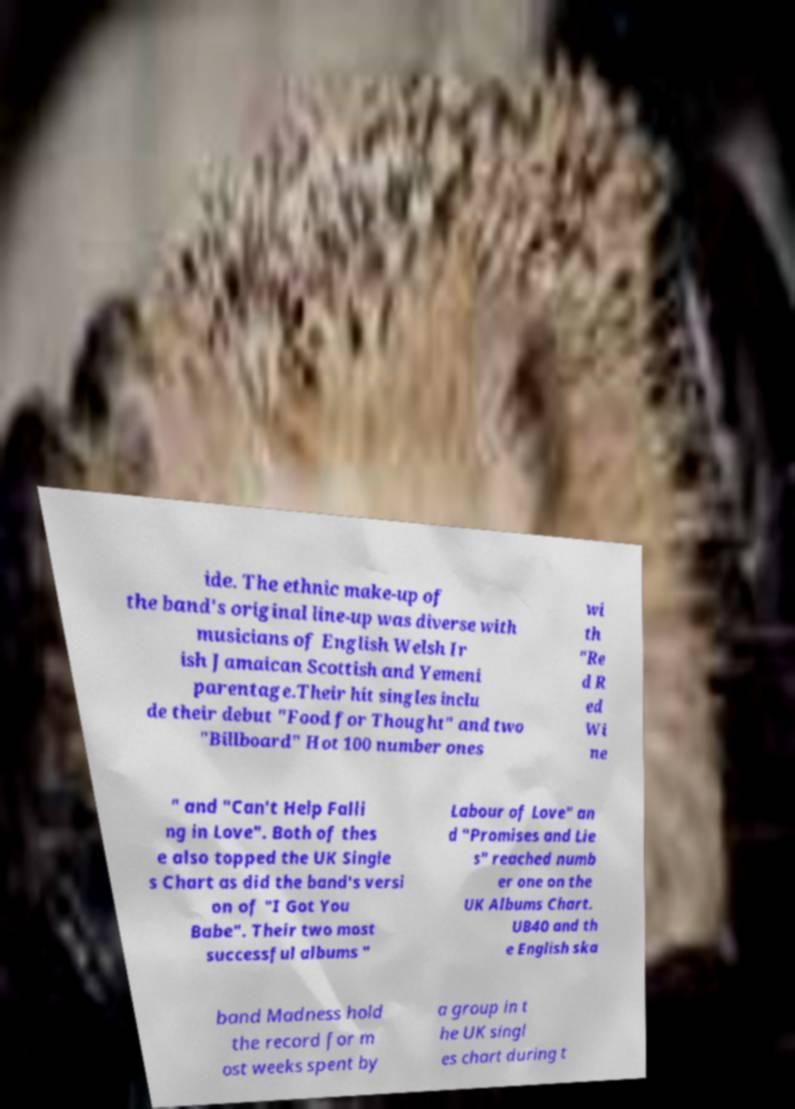Please identify and transcribe the text found in this image. ide. The ethnic make-up of the band's original line-up was diverse with musicians of English Welsh Ir ish Jamaican Scottish and Yemeni parentage.Their hit singles inclu de their debut "Food for Thought" and two "Billboard" Hot 100 number ones wi th "Re d R ed Wi ne " and "Can't Help Falli ng in Love". Both of thes e also topped the UK Single s Chart as did the band's versi on of "I Got You Babe". Their two most successful albums " Labour of Love" an d "Promises and Lie s" reached numb er one on the UK Albums Chart. UB40 and th e English ska band Madness hold the record for m ost weeks spent by a group in t he UK singl es chart during t 